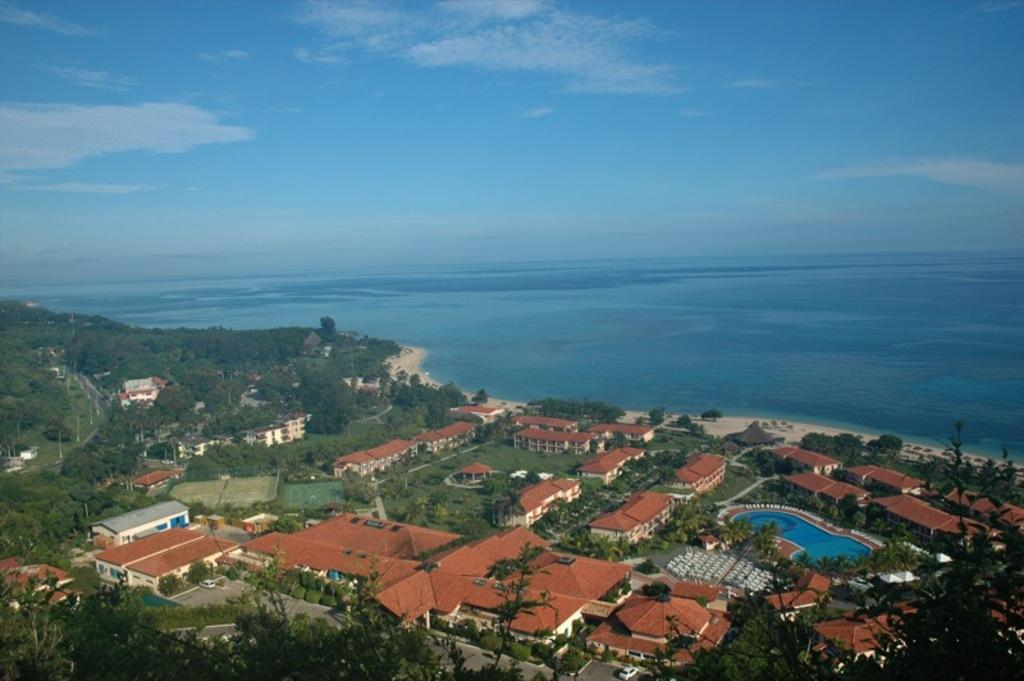What type of structures can be seen in the image? There are houses in the image. What other natural elements are present in the image? There are trees in the image. Are there any man-made objects visible in the image? Yes, there are poles in the image. What can be seen in the background of the image? There is water and clouds visible in the background of the image. How many mice can be seen climbing the poles in the image? There are no mice present in the image; it features houses, trees, poles, water, and clouds. Can you describe the snails' movement on the houses in the image? There are no snails present in the image; it features houses, trees, poles, water, and clouds. 